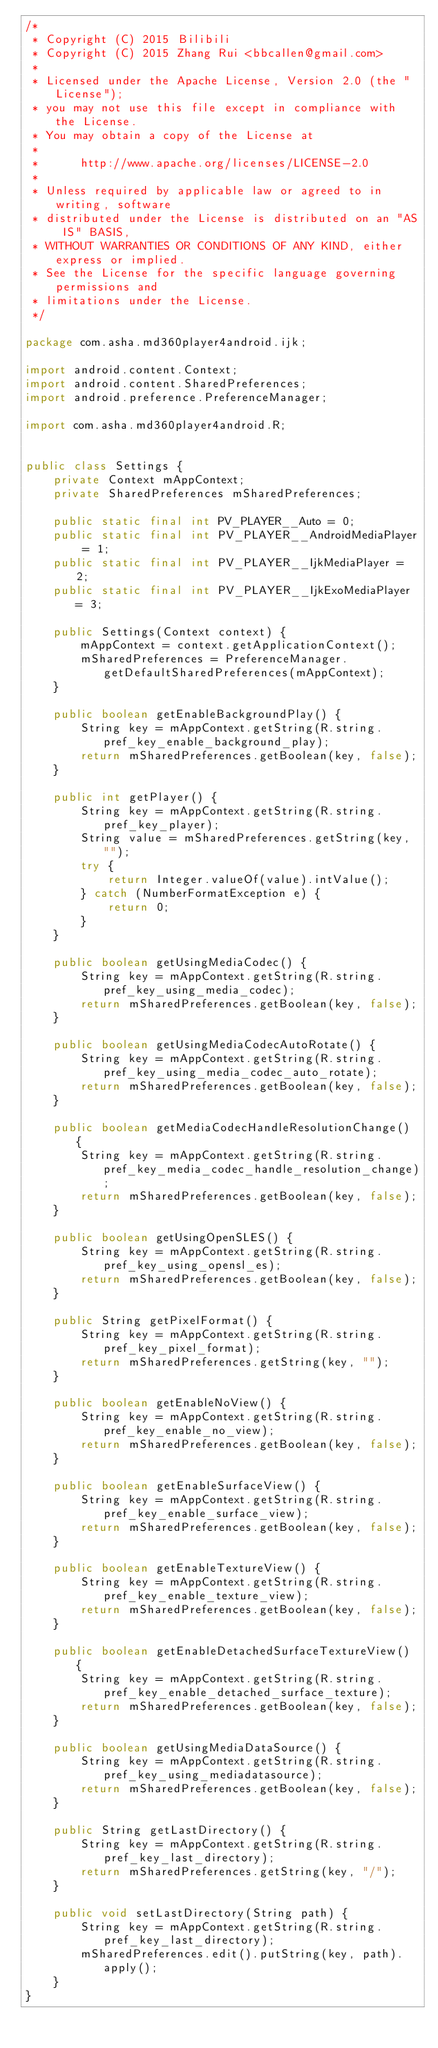Convert code to text. <code><loc_0><loc_0><loc_500><loc_500><_Java_>/*
 * Copyright (C) 2015 Bilibili
 * Copyright (C) 2015 Zhang Rui <bbcallen@gmail.com>
 *
 * Licensed under the Apache License, Version 2.0 (the "License");
 * you may not use this file except in compliance with the License.
 * You may obtain a copy of the License at
 *
 *      http://www.apache.org/licenses/LICENSE-2.0
 *
 * Unless required by applicable law or agreed to in writing, software
 * distributed under the License is distributed on an "AS IS" BASIS,
 * WITHOUT WARRANTIES OR CONDITIONS OF ANY KIND, either express or implied.
 * See the License for the specific language governing permissions and
 * limitations under the License.
 */

package com.asha.md360player4android.ijk;

import android.content.Context;
import android.content.SharedPreferences;
import android.preference.PreferenceManager;

import com.asha.md360player4android.R;


public class Settings {
    private Context mAppContext;
    private SharedPreferences mSharedPreferences;

    public static final int PV_PLAYER__Auto = 0;
    public static final int PV_PLAYER__AndroidMediaPlayer = 1;
    public static final int PV_PLAYER__IjkMediaPlayer = 2;
    public static final int PV_PLAYER__IjkExoMediaPlayer = 3;

    public Settings(Context context) {
        mAppContext = context.getApplicationContext();
        mSharedPreferences = PreferenceManager.getDefaultSharedPreferences(mAppContext);
    }

    public boolean getEnableBackgroundPlay() {
        String key = mAppContext.getString(R.string.pref_key_enable_background_play);
        return mSharedPreferences.getBoolean(key, false);
    }

    public int getPlayer() {
        String key = mAppContext.getString(R.string.pref_key_player);
        String value = mSharedPreferences.getString(key, "");
        try {
            return Integer.valueOf(value).intValue();
        } catch (NumberFormatException e) {
            return 0;
        }
    }

    public boolean getUsingMediaCodec() {
        String key = mAppContext.getString(R.string.pref_key_using_media_codec);
        return mSharedPreferences.getBoolean(key, false);
    }

    public boolean getUsingMediaCodecAutoRotate() {
        String key = mAppContext.getString(R.string.pref_key_using_media_codec_auto_rotate);
        return mSharedPreferences.getBoolean(key, false);
    }

    public boolean getMediaCodecHandleResolutionChange() {
        String key = mAppContext.getString(R.string.pref_key_media_codec_handle_resolution_change);
        return mSharedPreferences.getBoolean(key, false);
    }

    public boolean getUsingOpenSLES() {
        String key = mAppContext.getString(R.string.pref_key_using_opensl_es);
        return mSharedPreferences.getBoolean(key, false);
    }

    public String getPixelFormat() {
        String key = mAppContext.getString(R.string.pref_key_pixel_format);
        return mSharedPreferences.getString(key, "");
    }

    public boolean getEnableNoView() {
        String key = mAppContext.getString(R.string.pref_key_enable_no_view);
        return mSharedPreferences.getBoolean(key, false);
    }

    public boolean getEnableSurfaceView() {
        String key = mAppContext.getString(R.string.pref_key_enable_surface_view);
        return mSharedPreferences.getBoolean(key, false);
    }

    public boolean getEnableTextureView() {
        String key = mAppContext.getString(R.string.pref_key_enable_texture_view);
        return mSharedPreferences.getBoolean(key, false);
    }

    public boolean getEnableDetachedSurfaceTextureView() {
        String key = mAppContext.getString(R.string.pref_key_enable_detached_surface_texture);
        return mSharedPreferences.getBoolean(key, false);
    }

    public boolean getUsingMediaDataSource() {
        String key = mAppContext.getString(R.string.pref_key_using_mediadatasource);
        return mSharedPreferences.getBoolean(key, false);
    }

    public String getLastDirectory() {
        String key = mAppContext.getString(R.string.pref_key_last_directory);
        return mSharedPreferences.getString(key, "/");
    }

    public void setLastDirectory(String path) {
        String key = mAppContext.getString(R.string.pref_key_last_directory);
        mSharedPreferences.edit().putString(key, path).apply();
    }
}
</code> 